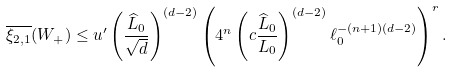<formula> <loc_0><loc_0><loc_500><loc_500>\overline { \xi _ { 2 , 1 } } ( W _ { + } ) \leq u ^ { \prime } \left ( \frac { \widehat { L } _ { 0 } } { \sqrt { d } } \right ) ^ { ( d - 2 ) } \left ( 4 ^ { n } \left ( c \frac { \widehat { L } _ { 0 } } { L _ { 0 } } \right ) ^ { ( d - 2 ) } \ell _ { 0 } ^ { - ( n + 1 ) ( d - 2 ) } \right ) ^ { r } .</formula> 